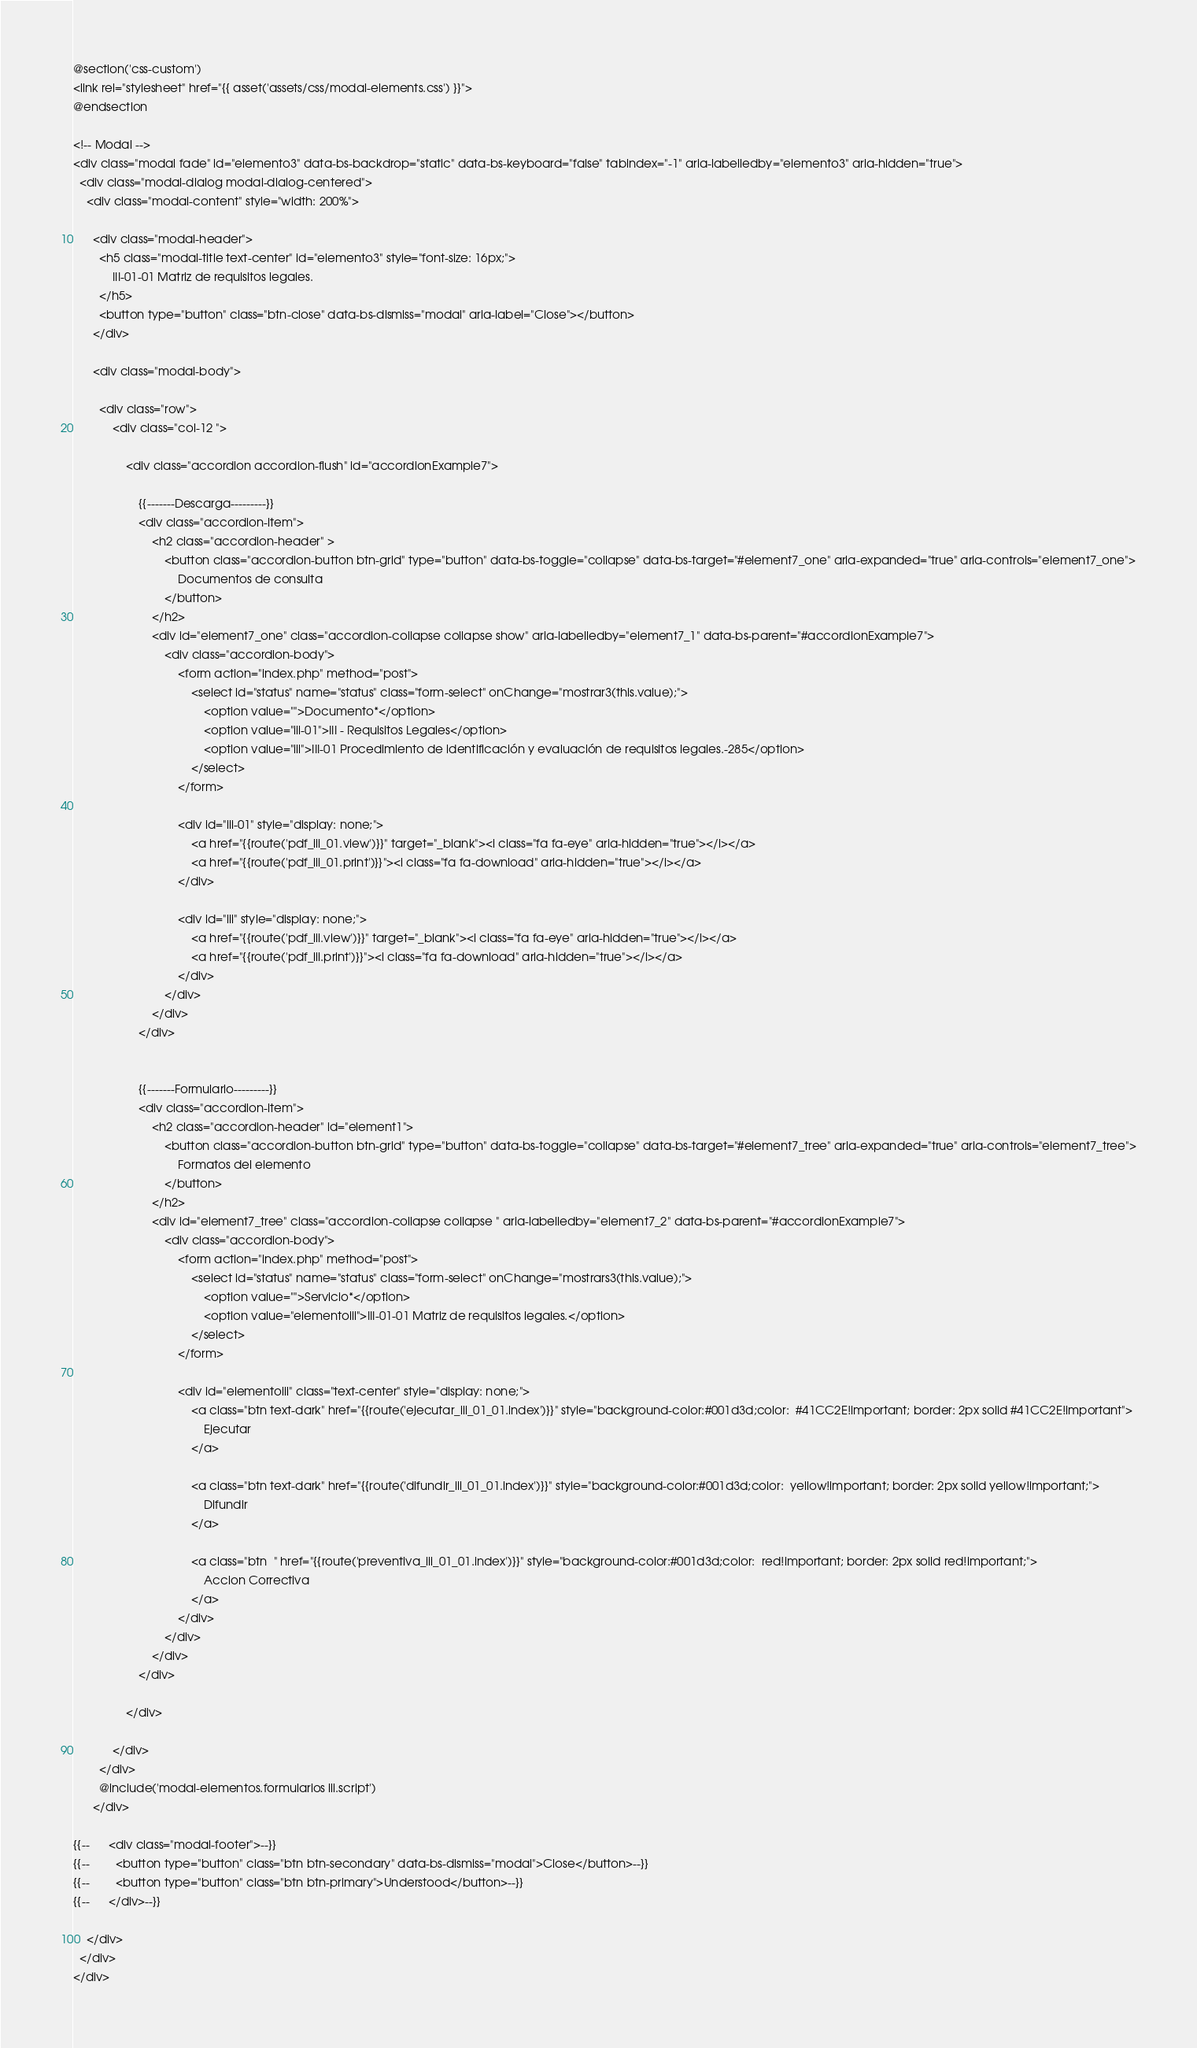<code> <loc_0><loc_0><loc_500><loc_500><_PHP_>@section('css-custom')
<link rel="stylesheet" href="{{ asset('assets/css/modal-elements.css') }}">
@endsection

<!-- Modal -->
<div class="modal fade" id="elemento3" data-bs-backdrop="static" data-bs-keyboard="false" tabindex="-1" aria-labelledby="elemento3" aria-hidden="true">
  <div class="modal-dialog modal-dialog-centered">
    <div class="modal-content" style="width: 200%">

      <div class="modal-header">
        <h5 class="modal-title text-center" id="elemento3" style="font-size: 16px;">
            III-01-01 Matriz de requisitos legales.
        </h5>
        <button type="button" class="btn-close" data-bs-dismiss="modal" aria-label="Close"></button>
      </div>

      <div class="modal-body">

        <div class="row">
            <div class="col-12 ">

                <div class="accordion accordion-flush" id="accordionExample7">

                    {{-------Descarga---------}}
                    <div class="accordion-item">
                        <h2 class="accordion-header" >
                            <button class="accordion-button btn-grid" type="button" data-bs-toggle="collapse" data-bs-target="#element7_one" aria-expanded="true" aria-controls="element7_one">
                                Documentos de consulta
                            </button>
                        </h2>
                        <div id="element7_one" class="accordion-collapse collapse show" aria-labelledby="element7_1" data-bs-parent="#accordionExample7">
                            <div class="accordion-body">
                                <form action="index.php" method="post">
                                    <select id="status" name="status" class="form-select" onChange="mostrar3(this.value);">
                                        <option value="">Documento*</option>
                                        <option value="iii-01">III - Requisitos Legales</option>
                                        <option value="iii">III-01 Procedimiento de identificación y evaluación de requisitos legales.-285</option>
                                    </select>
                                </form>

                                <div id="iii-01" style="display: none;">
                                    <a href="{{route('pdf_iii_01.view')}}" target="_blank"><i class="fa fa-eye" aria-hidden="true"></i></a>
                                    <a href="{{route('pdf_iii_01.print')}}"><i class="fa fa-download" aria-hidden="true"></i></a>
                                </div>

                                <div id="iii" style="display: none;">
                                    <a href="{{route('pdf_iii.view')}}" target="_blank"><i class="fa fa-eye" aria-hidden="true"></i></a>
                                    <a href="{{route('pdf_iii.print')}}"><i class="fa fa-download" aria-hidden="true"></i></a>
                                </div>
                            </div>
                        </div>
                    </div>


                    {{-------Formulario---------}}
                    <div class="accordion-item">
                        <h2 class="accordion-header" id="element1">
                            <button class="accordion-button btn-grid" type="button" data-bs-toggle="collapse" data-bs-target="#element7_tree" aria-expanded="true" aria-controls="element7_tree">
                                Formatos del elemento
                            </button>
                        </h2>
                        <div id="element7_tree" class="accordion-collapse collapse " aria-labelledby="element7_2" data-bs-parent="#accordionExample7">
                            <div class="accordion-body">
                                <form action="index.php" method="post">
                                    <select id="status" name="status" class="form-select" onChange="mostrars3(this.value);">
                                        <option value="">Servicio*</option>
                                        <option value="elementoiii">III-01-01 Matriz de requisitos legales.</option>
                                    </select>
                                </form>

                                <div id="elementoiii" class="text-center" style="display: none;">
                                    <a class="btn text-dark" href="{{route('ejecutar_iii_01_01.index')}}" style="background-color:#001d3d;color:  #41CC2E!important; border: 2px solid #41CC2E!important">
                                        Ejecutar
                                    </a>

                                    <a class="btn text-dark" href="{{route('difundir_iii_01_01.index')}}" style="background-color:#001d3d;color:  yellow!important; border: 2px solid yellow!important;">
                                        Difundir
                                    </a>

                                    <a class="btn  " href="{{route('preventiva_iii_01_01.index')}}" style="background-color:#001d3d;color:  red!important; border: 2px solid red!important;">
                                        Accion Correctiva
                                    </a>
                                </div>
                            </div>
                        </div>
                    </div>

                </div>

            </div>
        </div>
        @include('modal-elementos.formularios iii.script')
      </div>

{{--      <div class="modal-footer">--}}
{{--        <button type="button" class="btn btn-secondary" data-bs-dismiss="modal">Close</button>--}}
{{--        <button type="button" class="btn btn-primary">Understood</button>--}}
{{--      </div>--}}

    </div>
  </div>
</div>
</code> 